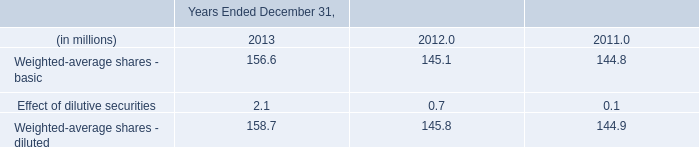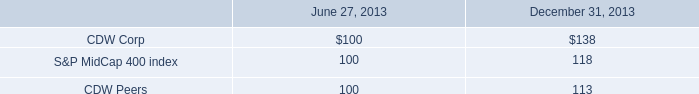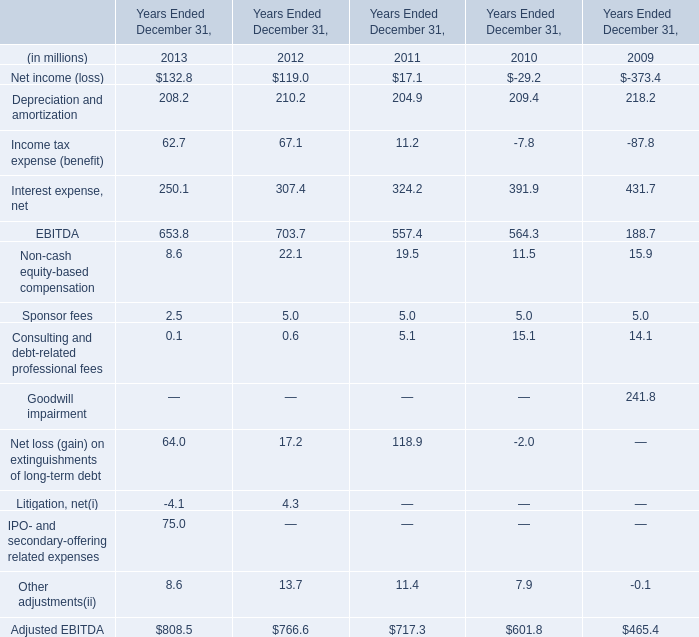under the rdu program in 2013 , what was the average of the two semi-annual interest payments , in millions? 
Computations: ((1.7 + 1.3) / 2)
Answer: 1.5. 